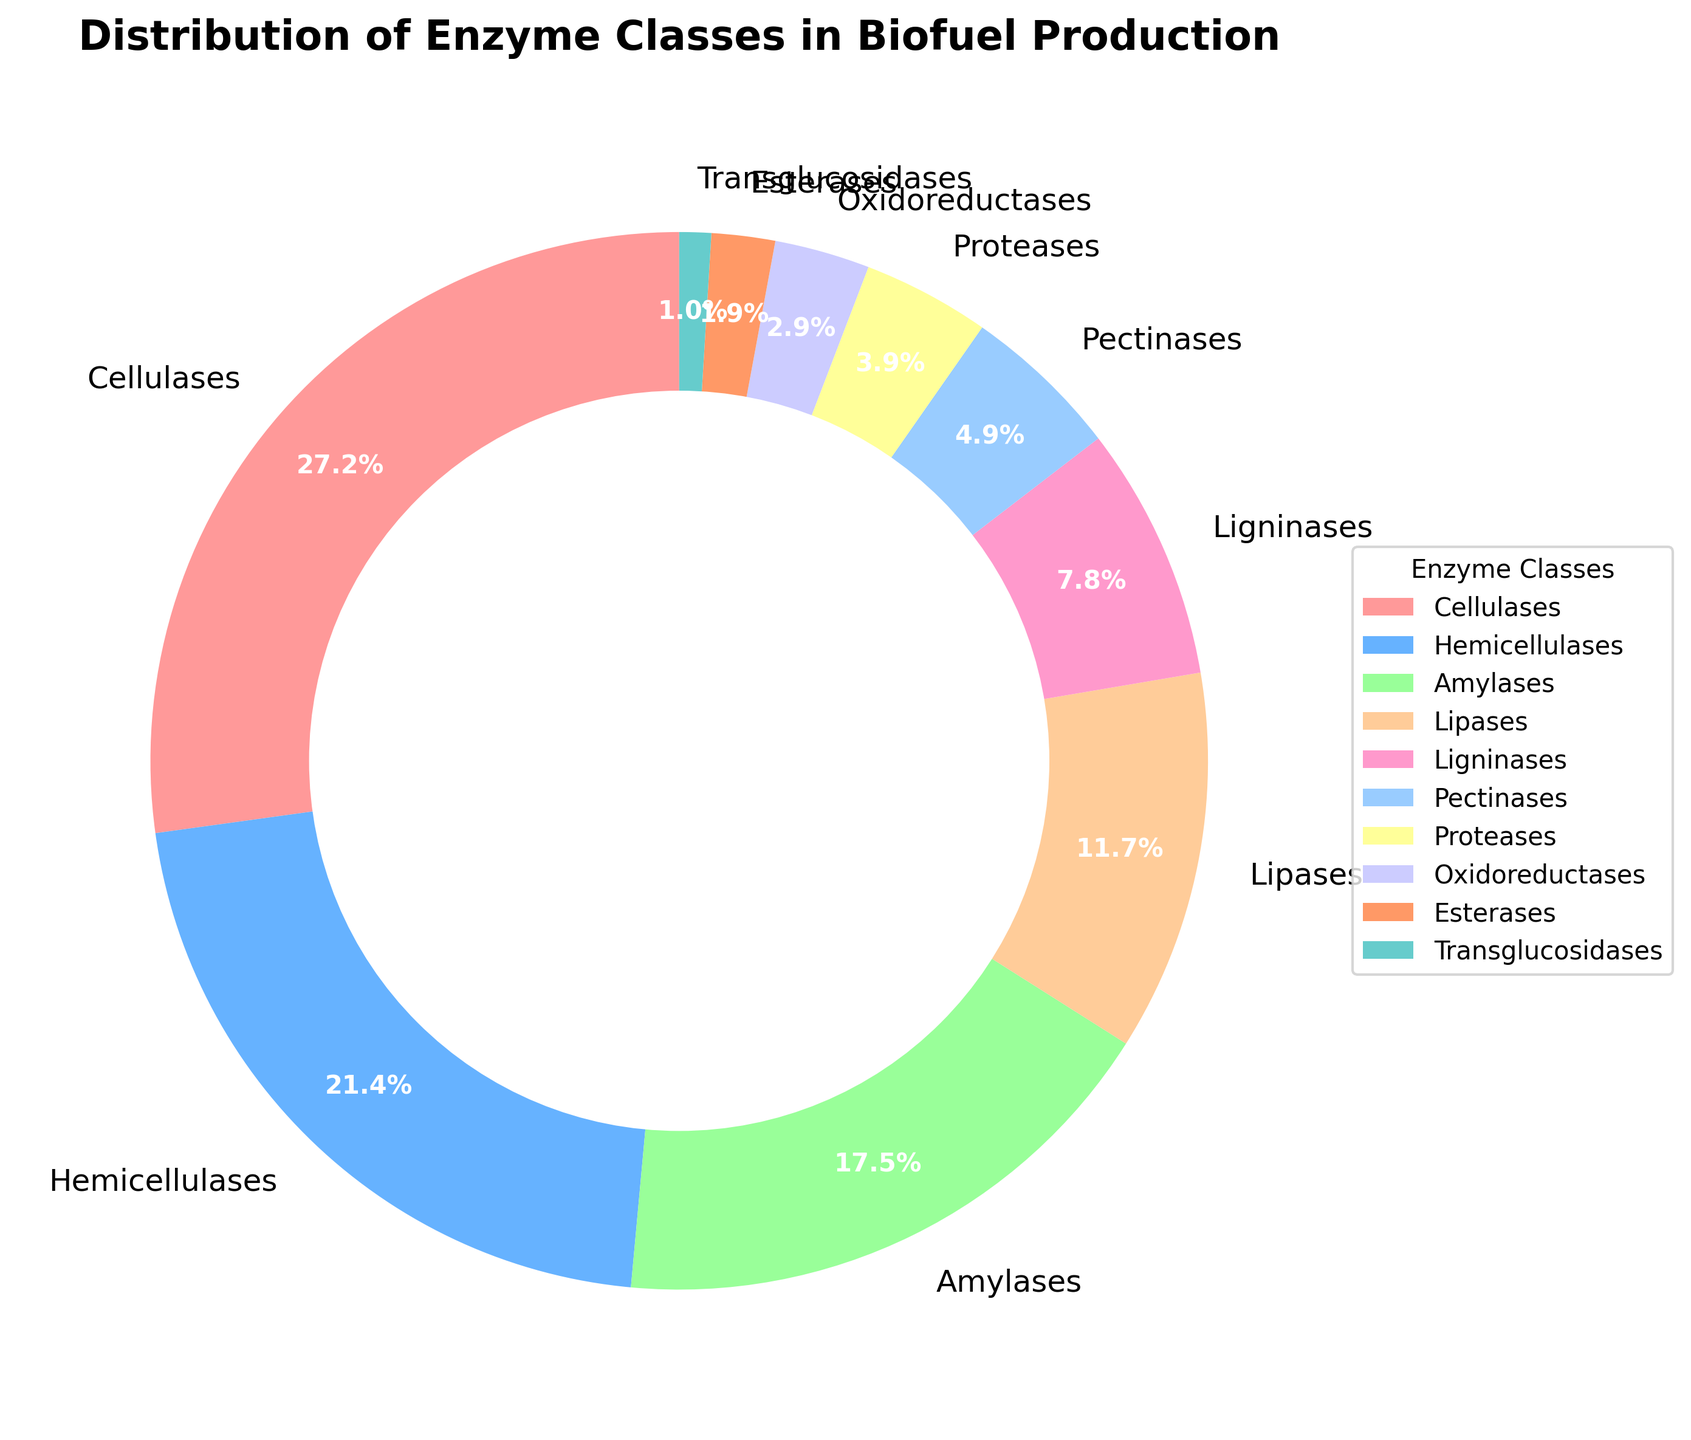What percentage of the enzymes used in biofuel production are cellulases? In the pie chart, the percentage of cellulases is directly shown as 28%.
Answer: 28% Which enzyme class has the smallest percentage share? By looking at the pie chart, we see that Transglucosidases have the smallest slice, labeled with 1%.
Answer: Transglucosidases How much greater is the percentage of hemicellulases compared to transglucosidases? From the pie chart, hemicellulases make up 22% and transglucosidases make up 1%. The difference is 22% - 1% = 21%.
Answer: 21% What is the combined percentage of cellulases and hemicellulases? The pie chart shows that cellulases are 28% and hemicellulases are 22%. The combined percentage is 28% + 22% = 50%.
Answer: 50% Which two enzyme classes together have a percentage greater than ligninases but less than hemicellulases? Ligninases have 8%, so combinations must be greater than 8% but less than 22%. Pectinases (5%) + Proteases (4%) = 9%. Esterases (2%) + Oxidoreductases (3%) = 5%, which doesn't work. Therefore, Pectinases and Proteases together have 9%.
Answer: Pectinases and Proteases If the enzyme classes Lipases and Amylases were removed, what would be the total percentage of the remaining classes? The pie chart shows Lipases as 12% and Amylases as 18%. Removing these percentages from 100%: 100% - 12% - 18% = 70%.
Answer: 70% Which enzyme class has a percentage closest to 10%? The pie chart shows that Lipases, at 12%, are the closest to 10%.
Answer: Lipases Are the combined percentages of Proteases and Esterases more or less than the percentage of Hemicellulases? The pie chart shows Proteases at 4% and Esterases at 2%. Their combined percentage is 4% + 2% = 6%, which is less than the 22% of Hemicellulases.
Answer: Less Which enzyme class has a slice with a reddish color? The pie chart uses specific colors; Cellulases (28%) have a reddish slice.
Answer: Cellulases 